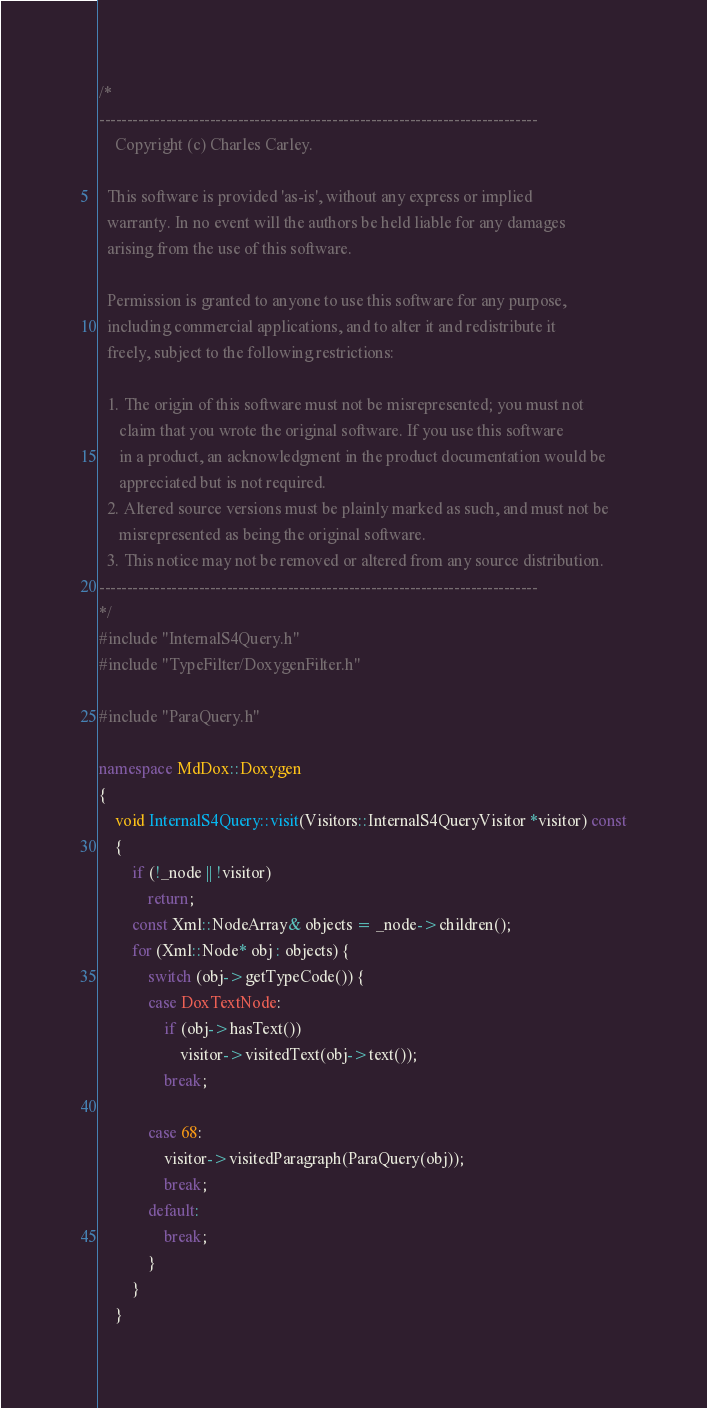Convert code to text. <code><loc_0><loc_0><loc_500><loc_500><_C++_>/*
-------------------------------------------------------------------------------
    Copyright (c) Charles Carley.

  This software is provided 'as-is', without any express or implied
  warranty. In no event will the authors be held liable for any damages
  arising from the use of this software.

  Permission is granted to anyone to use this software for any purpose,
  including commercial applications, and to alter it and redistribute it
  freely, subject to the following restrictions:

  1. The origin of this software must not be misrepresented; you must not
     claim that you wrote the original software. If you use this software
     in a product, an acknowledgment in the product documentation would be
     appreciated but is not required.
  2. Altered source versions must be plainly marked as such, and must not be
     misrepresented as being the original software.
  3. This notice may not be removed or altered from any source distribution.
-------------------------------------------------------------------------------
*/
#include "InternalS4Query.h"
#include "TypeFilter/DoxygenFilter.h"

#include "ParaQuery.h"

namespace MdDox::Doxygen
{
    void InternalS4Query::visit(Visitors::InternalS4QueryVisitor *visitor) const
    {
        if (!_node || !visitor)
            return;
        const Xml::NodeArray& objects = _node->children();
        for (Xml::Node* obj : objects) {
            switch (obj->getTypeCode()) {
            case DoxTextNode:
                if (obj->hasText())
                    visitor->visitedText(obj->text());
                break;

            case 68:
                visitor->visitedParagraph(ParaQuery(obj));
                break;        
            default:
                break;
            }
        }
    }</code> 